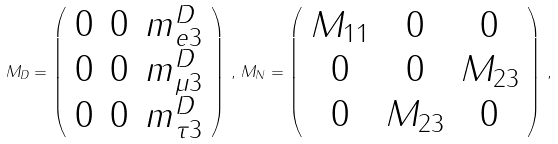<formula> <loc_0><loc_0><loc_500><loc_500>M _ { D } = \left ( \begin{array} { c c c } 0 & 0 & m ^ { D } _ { e 3 } \\ 0 & 0 & m ^ { D } _ { \mu 3 } \\ 0 & 0 & m ^ { D } _ { \tau 3 } \end{array} \right ) \, , \, M _ { N } = \left ( \begin{array} { c c c } M _ { 1 1 } & 0 & 0 \\ 0 & 0 & M _ { 2 3 } \\ 0 & M _ { 2 3 } & 0 \end{array} \right ) \, ,</formula> 